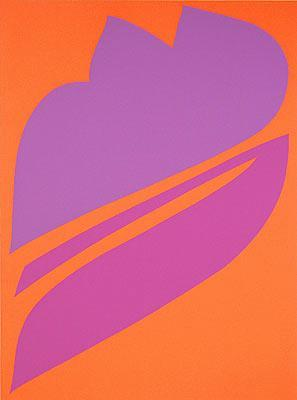Can you describe the emotions this artwork evokes? This artwork evokes a sense of vibrancy and energy due to the use of bright orange as the background color. The contrasting purple form in the center can elicit feelings of intrigue and contemplation. The simplicity of the intersecting lines and shapes may also evoke a serene and harmonious feeling, as the composition creates a balanced and expressive piece. 